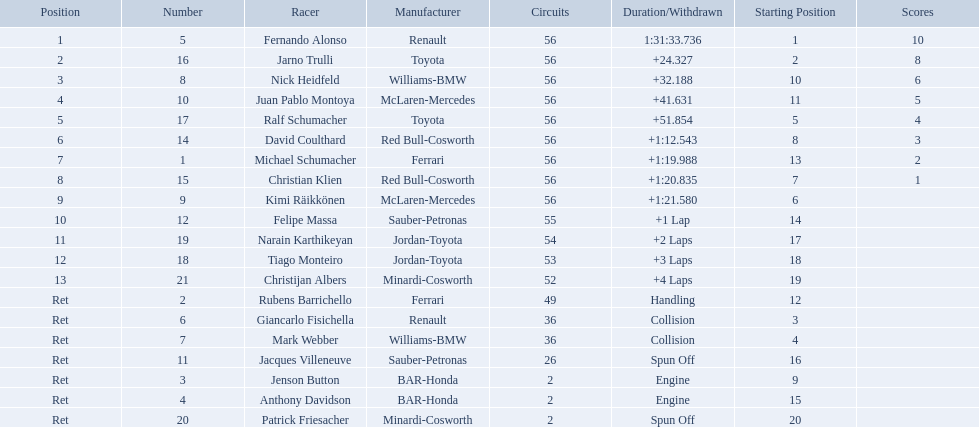Can you parse all the data within this table? {'header': ['Position', 'Number', 'Racer', 'Manufacturer', 'Circuits', 'Duration/Withdrawn', 'Starting Position', 'Scores'], 'rows': [['1', '5', 'Fernando Alonso', 'Renault', '56', '1:31:33.736', '1', '10'], ['2', '16', 'Jarno Trulli', 'Toyota', '56', '+24.327', '2', '8'], ['3', '8', 'Nick Heidfeld', 'Williams-BMW', '56', '+32.188', '10', '6'], ['4', '10', 'Juan Pablo Montoya', 'McLaren-Mercedes', '56', '+41.631', '11', '5'], ['5', '17', 'Ralf Schumacher', 'Toyota', '56', '+51.854', '5', '4'], ['6', '14', 'David Coulthard', 'Red Bull-Cosworth', '56', '+1:12.543', '8', '3'], ['7', '1', 'Michael Schumacher', 'Ferrari', '56', '+1:19.988', '13', '2'], ['8', '15', 'Christian Klien', 'Red Bull-Cosworth', '56', '+1:20.835', '7', '1'], ['9', '9', 'Kimi Räikkönen', 'McLaren-Mercedes', '56', '+1:21.580', '6', ''], ['10', '12', 'Felipe Massa', 'Sauber-Petronas', '55', '+1 Lap', '14', ''], ['11', '19', 'Narain Karthikeyan', 'Jordan-Toyota', '54', '+2 Laps', '17', ''], ['12', '18', 'Tiago Monteiro', 'Jordan-Toyota', '53', '+3 Laps', '18', ''], ['13', '21', 'Christijan Albers', 'Minardi-Cosworth', '52', '+4 Laps', '19', ''], ['Ret', '2', 'Rubens Barrichello', 'Ferrari', '49', 'Handling', '12', ''], ['Ret', '6', 'Giancarlo Fisichella', 'Renault', '36', 'Collision', '3', ''], ['Ret', '7', 'Mark Webber', 'Williams-BMW', '36', 'Collision', '4', ''], ['Ret', '11', 'Jacques Villeneuve', 'Sauber-Petronas', '26', 'Spun Off', '16', ''], ['Ret', '3', 'Jenson Button', 'BAR-Honda', '2', 'Engine', '9', ''], ['Ret', '4', 'Anthony Davidson', 'BAR-Honda', '2', 'Engine', '15', ''], ['Ret', '20', 'Patrick Friesacher', 'Minardi-Cosworth', '2', 'Spun Off', '20', '']]} Who was fernando alonso's instructor? Renault. How many laps did fernando alonso run? 56. How long did it take alonso to complete the race? 1:31:33.736. 